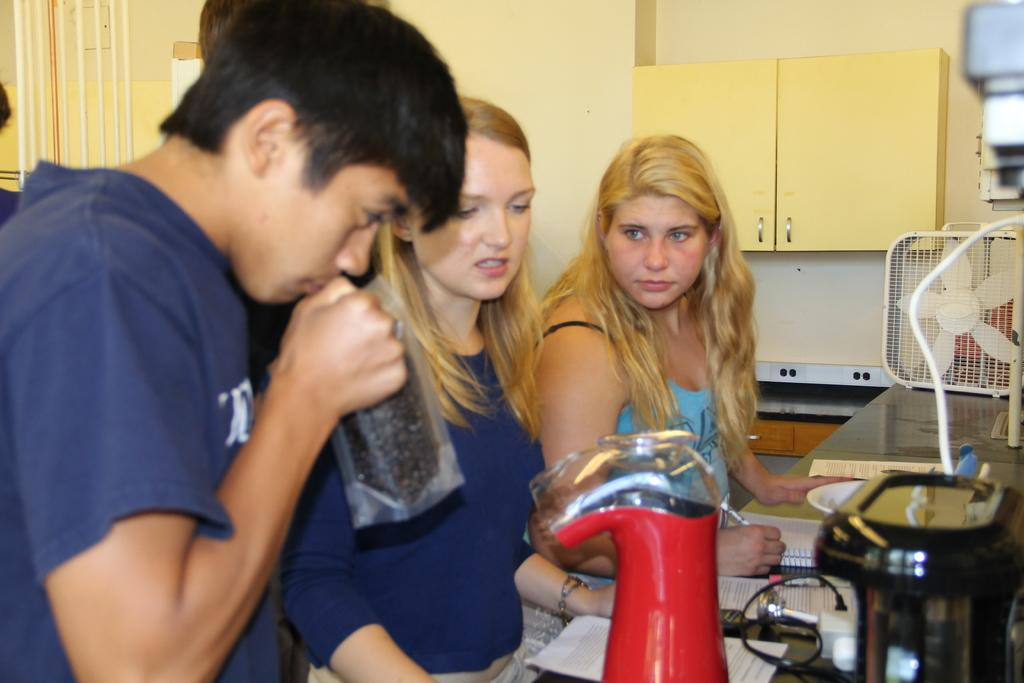What is happening in the image? There are people standing in the image. What can be seen on the platform in the image? There is a platform with objects in the image. What is visible in the background of the image? There is a wall in the background of the image. What type of furniture is present in the image? There is a cupboard in the image. What advice is being given on the page in the image? There is no page present in the image, so no advice can be given. 